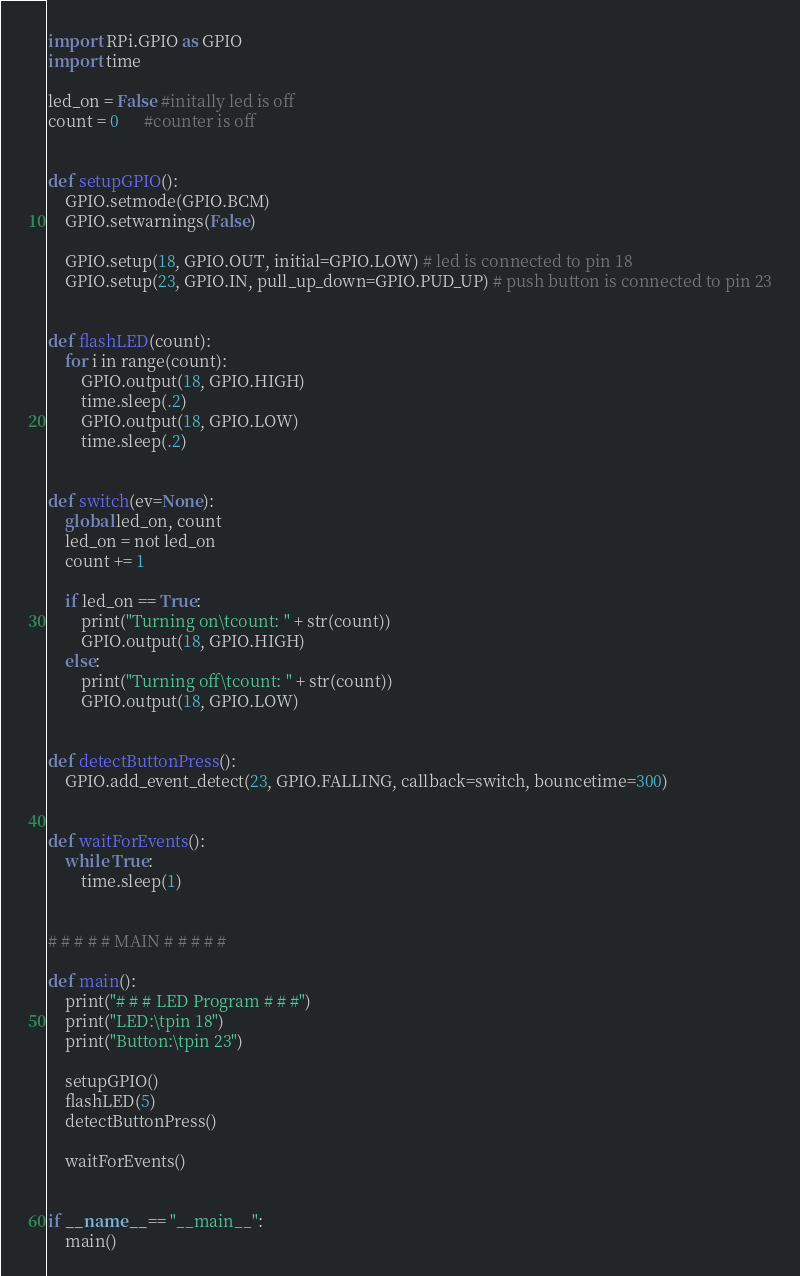<code> <loc_0><loc_0><loc_500><loc_500><_Python_>import RPi.GPIO as GPIO
import time

led_on = False #initally led is off
count = 0      #counter is off


def setupGPIO():
    GPIO.setmode(GPIO.BCM)
    GPIO.setwarnings(False)

    GPIO.setup(18, GPIO.OUT, initial=GPIO.LOW) # led is connected to pin 18
    GPIO.setup(23, GPIO.IN, pull_up_down=GPIO.PUD_UP) # push button is connected to pin 23


def flashLED(count):
    for i in range(count):
        GPIO.output(18, GPIO.HIGH)
        time.sleep(.2)
        GPIO.output(18, GPIO.LOW)
        time.sleep(.2)


def switch(ev=None):
    global led_on, count
    led_on = not led_on
    count += 1

    if led_on == True:
        print("Turning on\tcount: " + str(count))
        GPIO.output(18, GPIO.HIGH)
    else:
        print("Turning off\tcount: " + str(count))
        GPIO.output(18, GPIO.LOW)


def detectButtonPress():
    GPIO.add_event_detect(23, GPIO.FALLING, callback=switch, bouncetime=300)


def waitForEvents():
    while True:
        time.sleep(1)


# # # # # MAIN # # # # #

def main():
    print("# # # LED Program # # #")
    print("LED:\tpin 18")
    print("Button:\tpin 23")

    setupGPIO()
    flashLED(5)
    detectButtonPress()

    waitForEvents()


if __name__ == "__main__":
    main()
</code> 